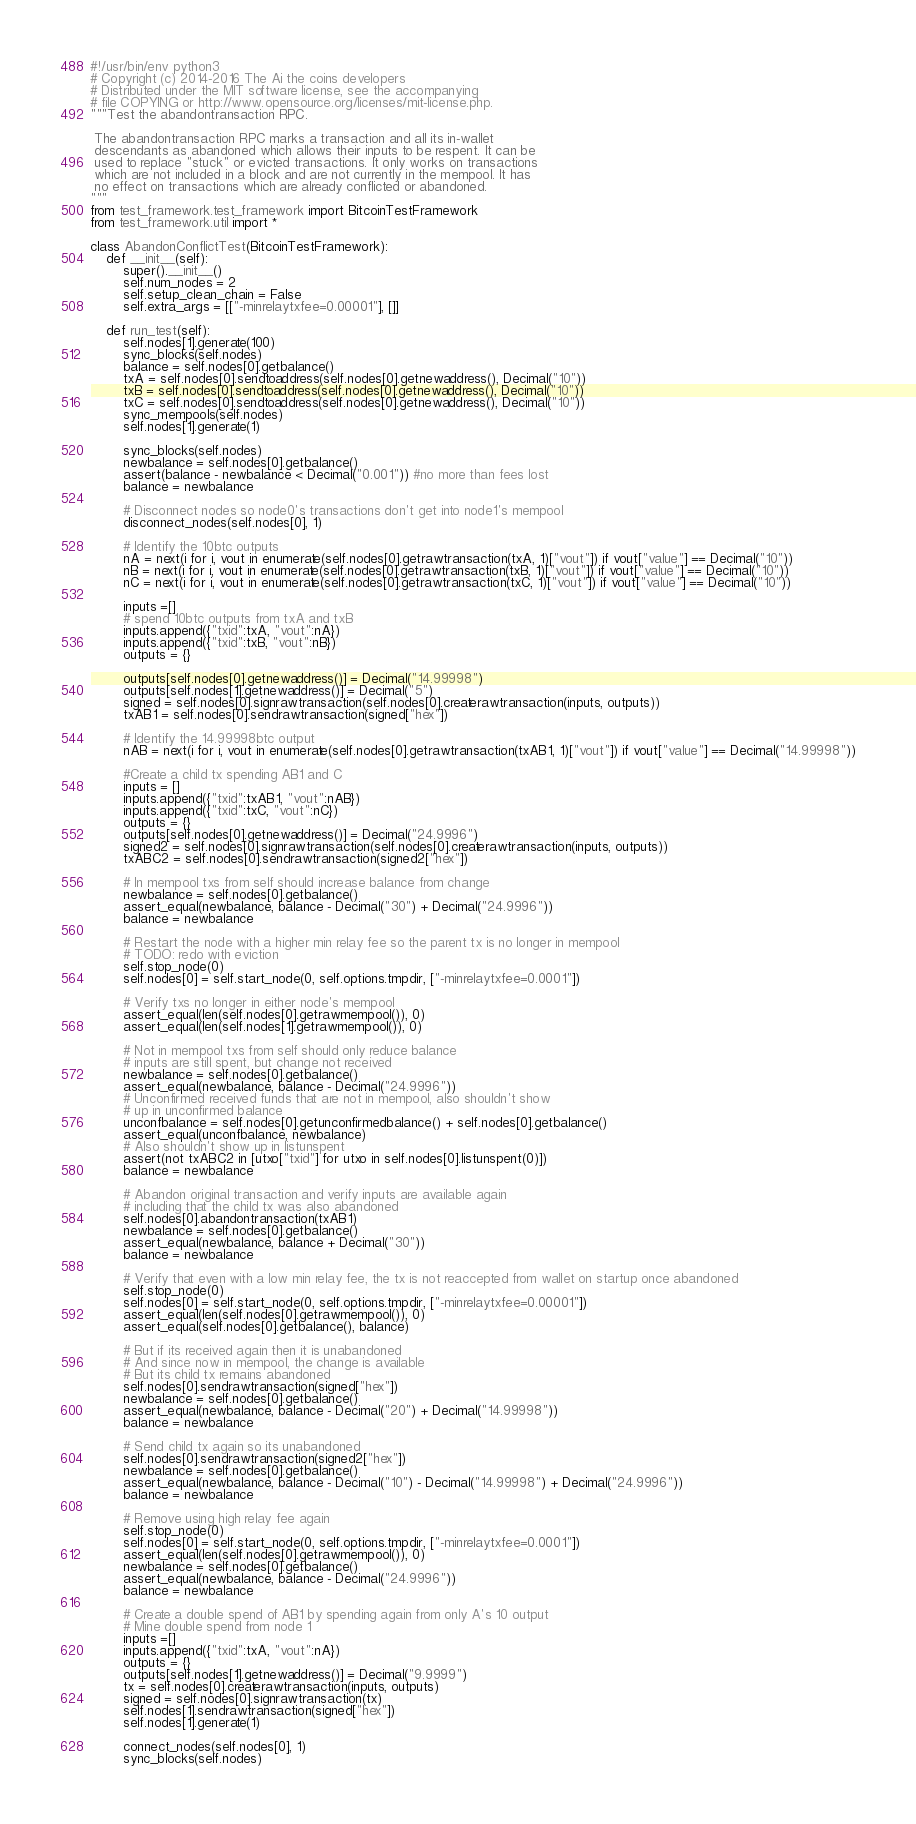Convert code to text. <code><loc_0><loc_0><loc_500><loc_500><_Python_>#!/usr/bin/env python3
# Copyright (c) 2014-2016 The Ai the coins developers
# Distributed under the MIT software license, see the accompanying
# file COPYING or http://www.opensource.org/licenses/mit-license.php.
"""Test the abandontransaction RPC.

 The abandontransaction RPC marks a transaction and all its in-wallet
 descendants as abandoned which allows their inputs to be respent. It can be
 used to replace "stuck" or evicted transactions. It only works on transactions
 which are not included in a block and are not currently in the mempool. It has
 no effect on transactions which are already conflicted or abandoned.
"""
from test_framework.test_framework import BitcoinTestFramework
from test_framework.util import *

class AbandonConflictTest(BitcoinTestFramework):
    def __init__(self):
        super().__init__()
        self.num_nodes = 2
        self.setup_clean_chain = False
        self.extra_args = [["-minrelaytxfee=0.00001"], []]

    def run_test(self):
        self.nodes[1].generate(100)
        sync_blocks(self.nodes)
        balance = self.nodes[0].getbalance()
        txA = self.nodes[0].sendtoaddress(self.nodes[0].getnewaddress(), Decimal("10"))
        txB = self.nodes[0].sendtoaddress(self.nodes[0].getnewaddress(), Decimal("10"))
        txC = self.nodes[0].sendtoaddress(self.nodes[0].getnewaddress(), Decimal("10"))
        sync_mempools(self.nodes)
        self.nodes[1].generate(1)

        sync_blocks(self.nodes)
        newbalance = self.nodes[0].getbalance()
        assert(balance - newbalance < Decimal("0.001")) #no more than fees lost
        balance = newbalance

        # Disconnect nodes so node0's transactions don't get into node1's mempool
        disconnect_nodes(self.nodes[0], 1)

        # Identify the 10btc outputs
        nA = next(i for i, vout in enumerate(self.nodes[0].getrawtransaction(txA, 1)["vout"]) if vout["value"] == Decimal("10"))
        nB = next(i for i, vout in enumerate(self.nodes[0].getrawtransaction(txB, 1)["vout"]) if vout["value"] == Decimal("10"))
        nC = next(i for i, vout in enumerate(self.nodes[0].getrawtransaction(txC, 1)["vout"]) if vout["value"] == Decimal("10"))

        inputs =[]
        # spend 10btc outputs from txA and txB
        inputs.append({"txid":txA, "vout":nA})
        inputs.append({"txid":txB, "vout":nB})
        outputs = {}

        outputs[self.nodes[0].getnewaddress()] = Decimal("14.99998")
        outputs[self.nodes[1].getnewaddress()] = Decimal("5")
        signed = self.nodes[0].signrawtransaction(self.nodes[0].createrawtransaction(inputs, outputs))
        txAB1 = self.nodes[0].sendrawtransaction(signed["hex"])

        # Identify the 14.99998btc output
        nAB = next(i for i, vout in enumerate(self.nodes[0].getrawtransaction(txAB1, 1)["vout"]) if vout["value"] == Decimal("14.99998"))

        #Create a child tx spending AB1 and C
        inputs = []
        inputs.append({"txid":txAB1, "vout":nAB})
        inputs.append({"txid":txC, "vout":nC})
        outputs = {}
        outputs[self.nodes[0].getnewaddress()] = Decimal("24.9996")
        signed2 = self.nodes[0].signrawtransaction(self.nodes[0].createrawtransaction(inputs, outputs))
        txABC2 = self.nodes[0].sendrawtransaction(signed2["hex"])

        # In mempool txs from self should increase balance from change
        newbalance = self.nodes[0].getbalance()
        assert_equal(newbalance, balance - Decimal("30") + Decimal("24.9996"))
        balance = newbalance

        # Restart the node with a higher min relay fee so the parent tx is no longer in mempool
        # TODO: redo with eviction
        self.stop_node(0)
        self.nodes[0] = self.start_node(0, self.options.tmpdir, ["-minrelaytxfee=0.0001"])

        # Verify txs no longer in either node's mempool
        assert_equal(len(self.nodes[0].getrawmempool()), 0)
        assert_equal(len(self.nodes[1].getrawmempool()), 0)

        # Not in mempool txs from self should only reduce balance
        # inputs are still spent, but change not received
        newbalance = self.nodes[0].getbalance()
        assert_equal(newbalance, balance - Decimal("24.9996"))
        # Unconfirmed received funds that are not in mempool, also shouldn't show
        # up in unconfirmed balance
        unconfbalance = self.nodes[0].getunconfirmedbalance() + self.nodes[0].getbalance()
        assert_equal(unconfbalance, newbalance)
        # Also shouldn't show up in listunspent
        assert(not txABC2 in [utxo["txid"] for utxo in self.nodes[0].listunspent(0)])
        balance = newbalance

        # Abandon original transaction and verify inputs are available again
        # including that the child tx was also abandoned
        self.nodes[0].abandontransaction(txAB1)
        newbalance = self.nodes[0].getbalance()
        assert_equal(newbalance, balance + Decimal("30"))
        balance = newbalance

        # Verify that even with a low min relay fee, the tx is not reaccepted from wallet on startup once abandoned
        self.stop_node(0)
        self.nodes[0] = self.start_node(0, self.options.tmpdir, ["-minrelaytxfee=0.00001"])
        assert_equal(len(self.nodes[0].getrawmempool()), 0)
        assert_equal(self.nodes[0].getbalance(), balance)

        # But if its received again then it is unabandoned
        # And since now in mempool, the change is available
        # But its child tx remains abandoned
        self.nodes[0].sendrawtransaction(signed["hex"])
        newbalance = self.nodes[0].getbalance()
        assert_equal(newbalance, balance - Decimal("20") + Decimal("14.99998"))
        balance = newbalance

        # Send child tx again so its unabandoned
        self.nodes[0].sendrawtransaction(signed2["hex"])
        newbalance = self.nodes[0].getbalance()
        assert_equal(newbalance, balance - Decimal("10") - Decimal("14.99998") + Decimal("24.9996"))
        balance = newbalance

        # Remove using high relay fee again
        self.stop_node(0)
        self.nodes[0] = self.start_node(0, self.options.tmpdir, ["-minrelaytxfee=0.0001"])
        assert_equal(len(self.nodes[0].getrawmempool()), 0)
        newbalance = self.nodes[0].getbalance()
        assert_equal(newbalance, balance - Decimal("24.9996"))
        balance = newbalance

        # Create a double spend of AB1 by spending again from only A's 10 output
        # Mine double spend from node 1
        inputs =[]
        inputs.append({"txid":txA, "vout":nA})
        outputs = {}
        outputs[self.nodes[1].getnewaddress()] = Decimal("9.9999")
        tx = self.nodes[0].createrawtransaction(inputs, outputs)
        signed = self.nodes[0].signrawtransaction(tx)
        self.nodes[1].sendrawtransaction(signed["hex"])
        self.nodes[1].generate(1)

        connect_nodes(self.nodes[0], 1)
        sync_blocks(self.nodes)
</code> 